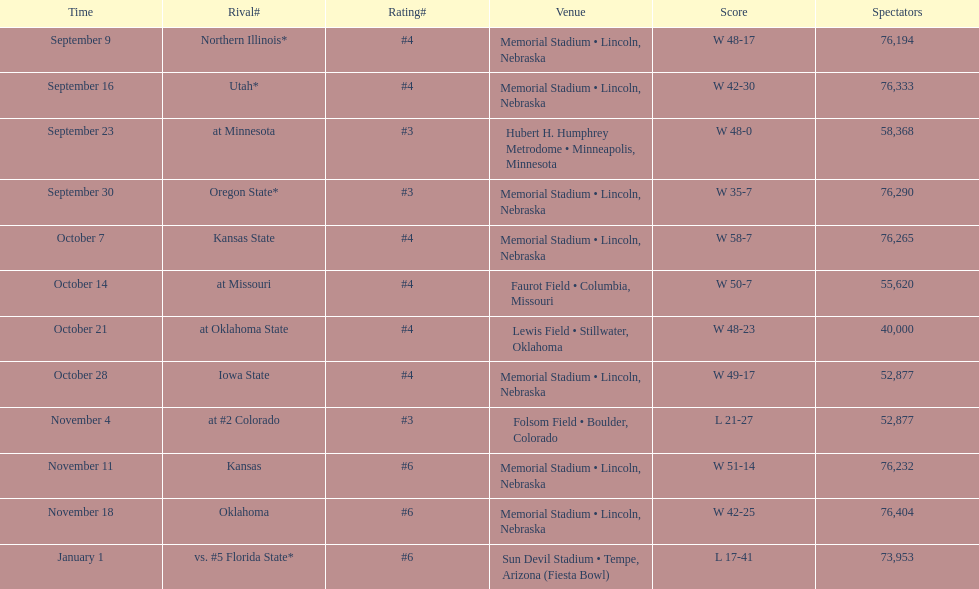How many games was their ranking not lower than #5? 9. Help me parse the entirety of this table. {'header': ['Time', 'Rival#', 'Rating#', 'Venue', 'Score', 'Spectators'], 'rows': [['September 9', 'Northern Illinois*', '#4', 'Memorial Stadium • Lincoln, Nebraska', 'W\xa048-17', '76,194'], ['September 16', 'Utah*', '#4', 'Memorial Stadium • Lincoln, Nebraska', 'W\xa042-30', '76,333'], ['September 23', 'at\xa0Minnesota', '#3', 'Hubert H. Humphrey Metrodome • Minneapolis, Minnesota', 'W\xa048-0', '58,368'], ['September 30', 'Oregon State*', '#3', 'Memorial Stadium • Lincoln, Nebraska', 'W\xa035-7', '76,290'], ['October 7', 'Kansas State', '#4', 'Memorial Stadium • Lincoln, Nebraska', 'W\xa058-7', '76,265'], ['October 14', 'at\xa0Missouri', '#4', 'Faurot Field • Columbia, Missouri', 'W\xa050-7', '55,620'], ['October 21', 'at\xa0Oklahoma State', '#4', 'Lewis Field • Stillwater, Oklahoma', 'W\xa048-23', '40,000'], ['October 28', 'Iowa State', '#4', 'Memorial Stadium • Lincoln, Nebraska', 'W\xa049-17', '52,877'], ['November 4', 'at\xa0#2\xa0Colorado', '#3', 'Folsom Field • Boulder, Colorado', 'L\xa021-27', '52,877'], ['November 11', 'Kansas', '#6', 'Memorial Stadium • Lincoln, Nebraska', 'W\xa051-14', '76,232'], ['November 18', 'Oklahoma', '#6', 'Memorial Stadium • Lincoln, Nebraska', 'W\xa042-25', '76,404'], ['January 1', 'vs.\xa0#5\xa0Florida State*', '#6', 'Sun Devil Stadium • Tempe, Arizona (Fiesta Bowl)', 'L\xa017-41', '73,953']]} 